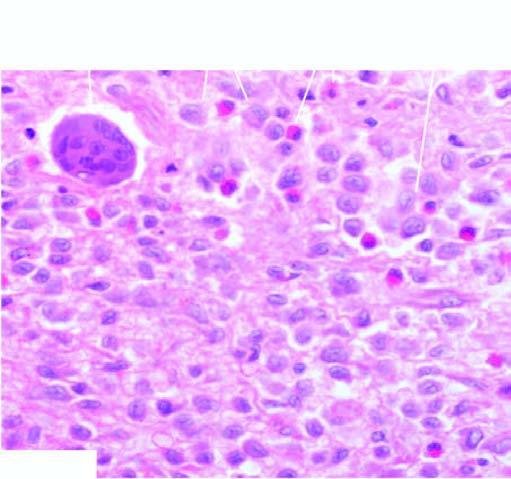what did collections of histiocytes have admixed with?
Answer the question using a single word or phrase. Eosinophils 